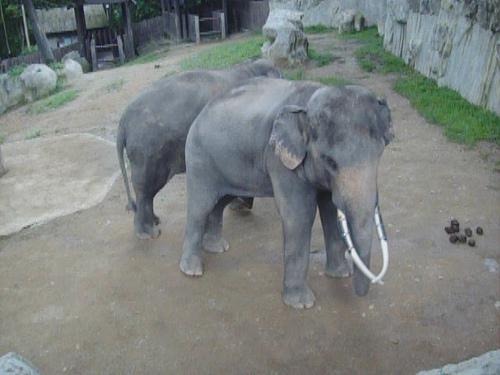Question: where was this picture taken?
Choices:
A. A zoo.
B. A park.
C. The wilderness.
D. A forest.
Answer with the letter. Answer: A Question: how many elephants are in this picture?
Choices:
A. Two.
B. None.
C. Three.
D. One.
Answer with the letter. Answer: A Question: what type of animals are in this picture?
Choices:
A. Hippos.
B. Rhinos.
C. Elephants.
D. Lions.
Answer with the letter. Answer: C Question: how many people are in this picture?
Choices:
A. Two.
B. One.
C. None.
D. Seven.
Answer with the letter. Answer: C Question: how many of the elephants' eyes are visible?
Choices:
A. Two.
B. Four.
C. One.
D. Five.
Answer with the letter. Answer: C Question: how many elephant tusks are visible in this picture?
Choices:
A. 0.
B. 2.
C. 1.
D. 3.
Answer with the letter. Answer: B Question: how many of the elephants' tails are visible in this picture?
Choices:
A. None.
B. One.
C. Three.
D. Two.
Answer with the letter. Answer: B 